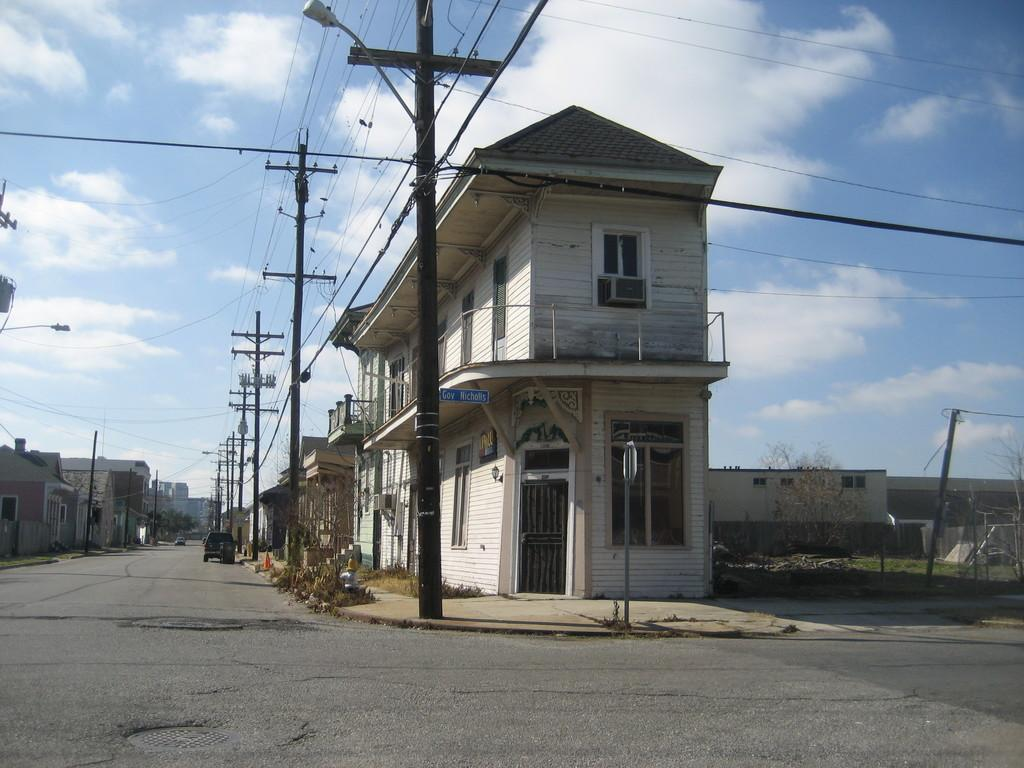What is on the road in the image? There is a vehicle on the road in the image. What can be seen in the image besides the vehicle? There are poles, wires, trees, plants, houses, and the sky visible in the image. What is the condition of the sky in the image? The sky is visible in the background of the image, and there are clouds in the sky. What type of belief can be seen in the image? There is no belief present in the image; it features a vehicle on the road, poles, wires, trees, plants, houses, and the sky. What is the cabbage doing in the image? There is no cabbage present in the image. 